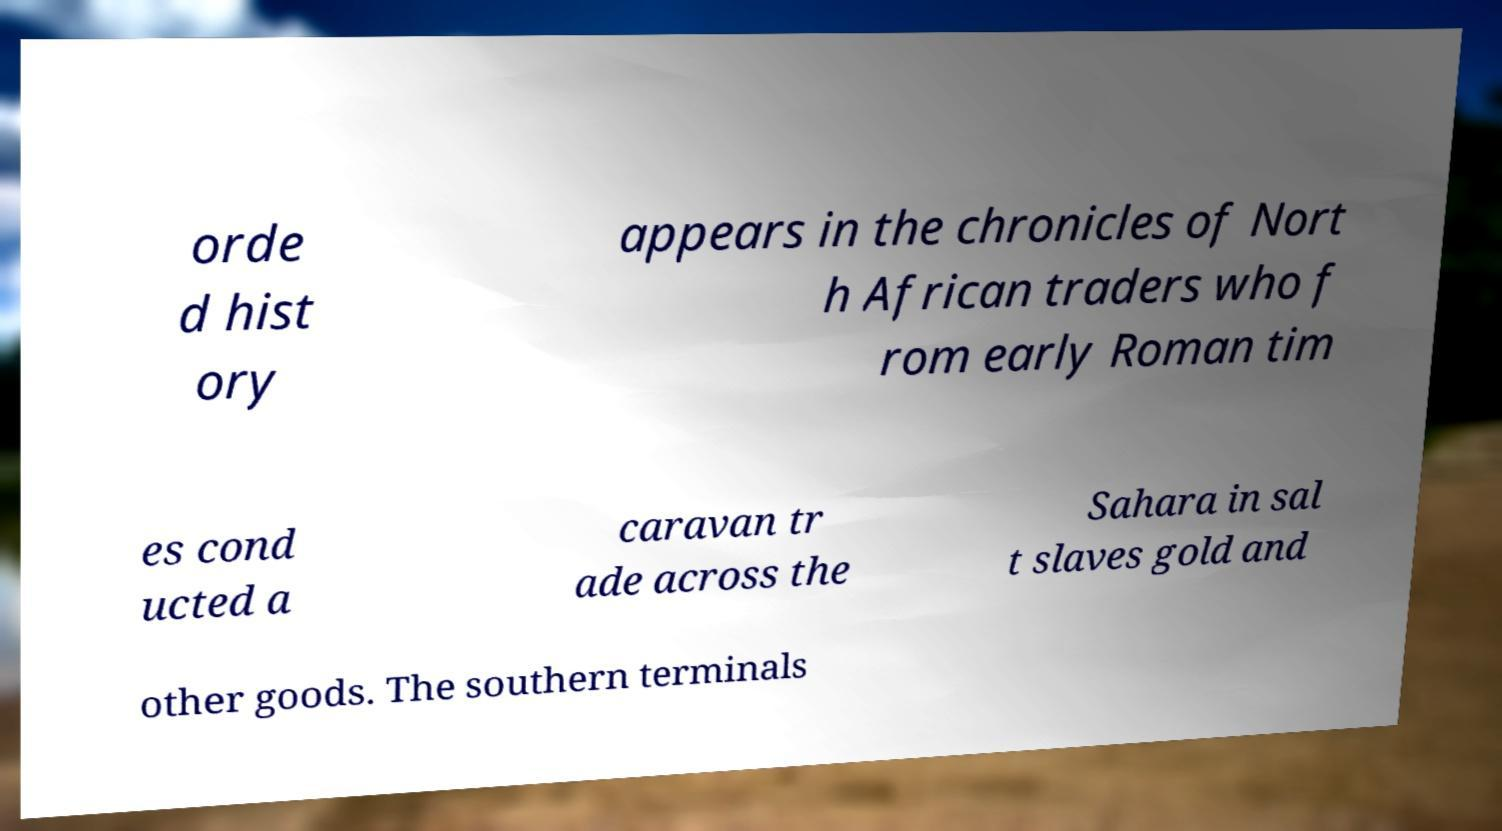There's text embedded in this image that I need extracted. Can you transcribe it verbatim? orde d hist ory appears in the chronicles of Nort h African traders who f rom early Roman tim es cond ucted a caravan tr ade across the Sahara in sal t slaves gold and other goods. The southern terminals 